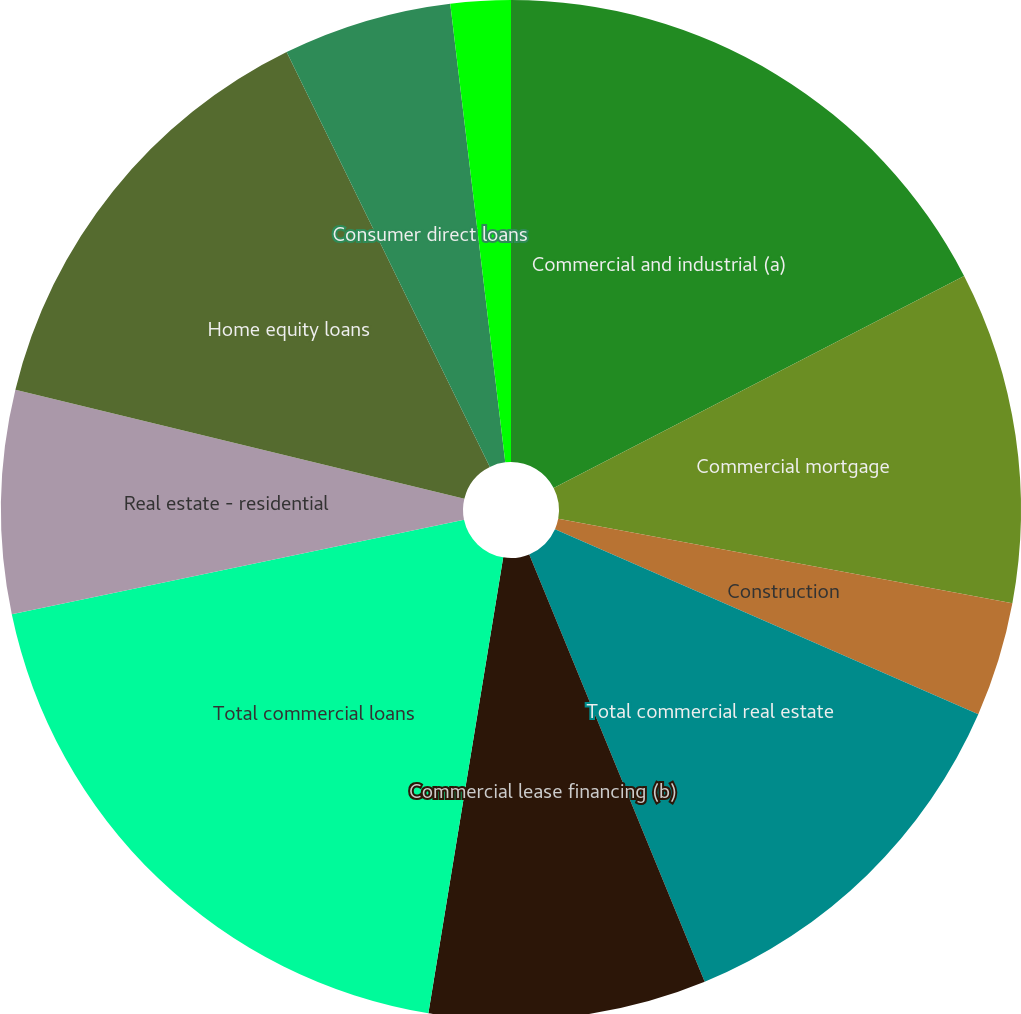Convert chart to OTSL. <chart><loc_0><loc_0><loc_500><loc_500><pie_chart><fcel>Commercial and industrial (a)<fcel>Commercial mortgage<fcel>Construction<fcel>Total commercial real estate<fcel>Commercial lease financing (b)<fcel>Total commercial loans<fcel>Real estate - residential<fcel>Home equity loans<fcel>Consumer direct loans<fcel>Credit cards<nl><fcel>17.41%<fcel>10.52%<fcel>3.63%<fcel>12.24%<fcel>8.79%<fcel>19.13%<fcel>7.07%<fcel>13.96%<fcel>5.35%<fcel>1.9%<nl></chart> 